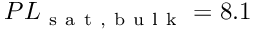Convert formula to latex. <formula><loc_0><loc_0><loc_500><loc_500>P L _ { s a t , b u l k } = 8 . 1</formula> 